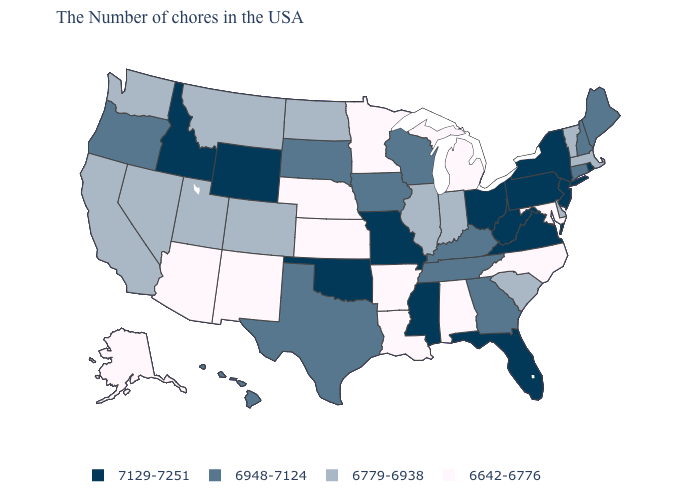Does Iowa have the same value as Minnesota?
Write a very short answer. No. What is the value of New Mexico?
Write a very short answer. 6642-6776. How many symbols are there in the legend?
Write a very short answer. 4. Name the states that have a value in the range 6948-7124?
Answer briefly. Maine, New Hampshire, Connecticut, Georgia, Kentucky, Tennessee, Wisconsin, Iowa, Texas, South Dakota, Oregon, Hawaii. What is the value of Delaware?
Keep it brief. 6779-6938. What is the highest value in states that border Wisconsin?
Write a very short answer. 6948-7124. Among the states that border Pennsylvania , does Ohio have the lowest value?
Give a very brief answer. No. What is the lowest value in the USA?
Give a very brief answer. 6642-6776. Name the states that have a value in the range 6948-7124?
Concise answer only. Maine, New Hampshire, Connecticut, Georgia, Kentucky, Tennessee, Wisconsin, Iowa, Texas, South Dakota, Oregon, Hawaii. What is the highest value in the USA?
Write a very short answer. 7129-7251. Name the states that have a value in the range 7129-7251?
Keep it brief. Rhode Island, New York, New Jersey, Pennsylvania, Virginia, West Virginia, Ohio, Florida, Mississippi, Missouri, Oklahoma, Wyoming, Idaho. Does Mississippi have a lower value than Arkansas?
Concise answer only. No. What is the value of California?
Short answer required. 6779-6938. Name the states that have a value in the range 6779-6938?
Concise answer only. Massachusetts, Vermont, Delaware, South Carolina, Indiana, Illinois, North Dakota, Colorado, Utah, Montana, Nevada, California, Washington. Is the legend a continuous bar?
Give a very brief answer. No. 